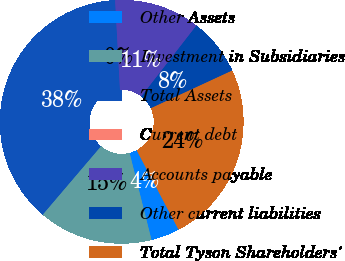<chart> <loc_0><loc_0><loc_500><loc_500><pie_chart><fcel>Other Assets<fcel>Investment in Subsidiaries<fcel>Total Assets<fcel>Current debt<fcel>Accounts payable<fcel>Other current liabilities<fcel>Total Tyson Shareholders'<nl><fcel>3.79%<fcel>15.16%<fcel>37.91%<fcel>0.0%<fcel>11.37%<fcel>7.58%<fcel>24.18%<nl></chart> 